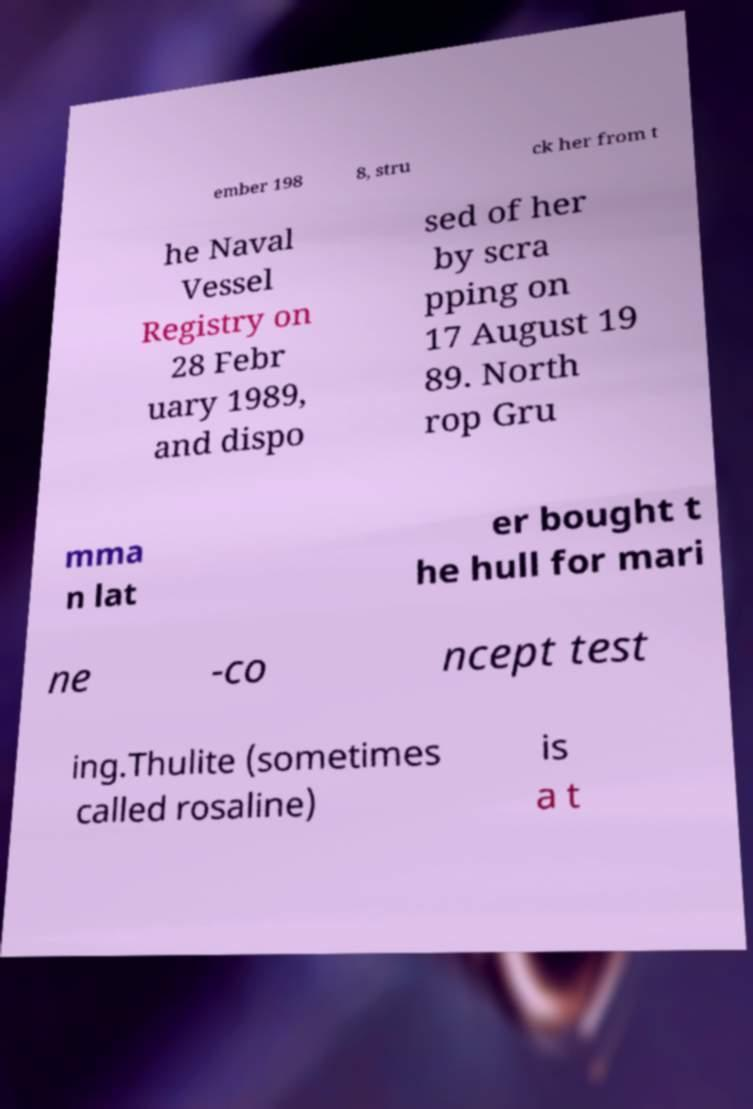Could you assist in decoding the text presented in this image and type it out clearly? ember 198 8, stru ck her from t he Naval Vessel Registry on 28 Febr uary 1989, and dispo sed of her by scra pping on 17 August 19 89. North rop Gru mma n lat er bought t he hull for mari ne -co ncept test ing.Thulite (sometimes called rosaline) is a t 